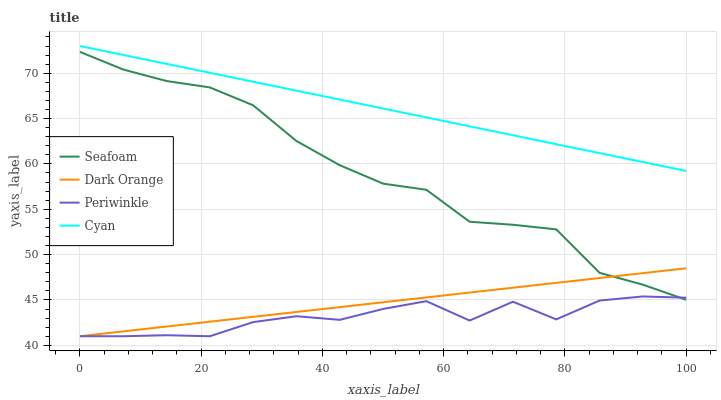Does Periwinkle have the minimum area under the curve?
Answer yes or no. Yes. Does Cyan have the maximum area under the curve?
Answer yes or no. Yes. Does Seafoam have the minimum area under the curve?
Answer yes or no. No. Does Seafoam have the maximum area under the curve?
Answer yes or no. No. Is Cyan the smoothest?
Answer yes or no. Yes. Is Periwinkle the roughest?
Answer yes or no. Yes. Is Seafoam the smoothest?
Answer yes or no. No. Is Seafoam the roughest?
Answer yes or no. No. Does Dark Orange have the lowest value?
Answer yes or no. Yes. Does Seafoam have the lowest value?
Answer yes or no. No. Does Cyan have the highest value?
Answer yes or no. Yes. Does Seafoam have the highest value?
Answer yes or no. No. Is Seafoam less than Cyan?
Answer yes or no. Yes. Is Cyan greater than Periwinkle?
Answer yes or no. Yes. Does Dark Orange intersect Seafoam?
Answer yes or no. Yes. Is Dark Orange less than Seafoam?
Answer yes or no. No. Is Dark Orange greater than Seafoam?
Answer yes or no. No. Does Seafoam intersect Cyan?
Answer yes or no. No. 